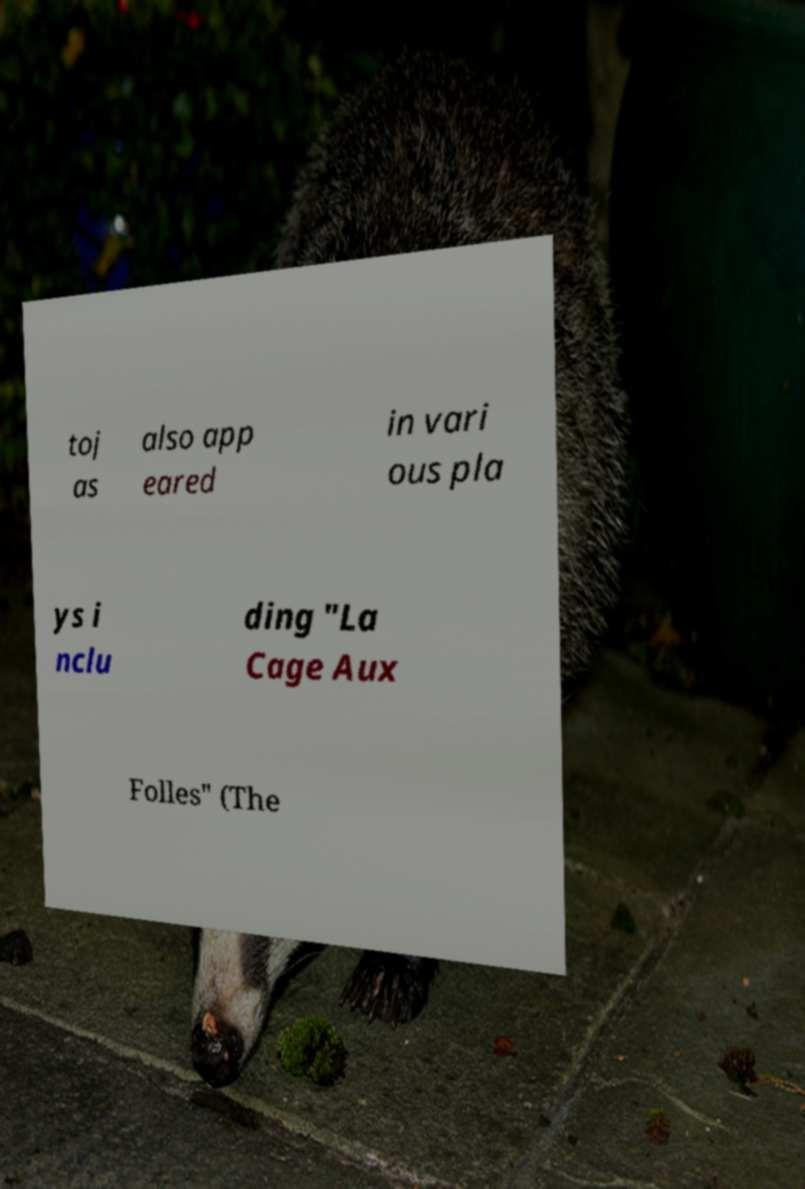What messages or text are displayed in this image? I need them in a readable, typed format. toj as also app eared in vari ous pla ys i nclu ding "La Cage Aux Folles" (The 